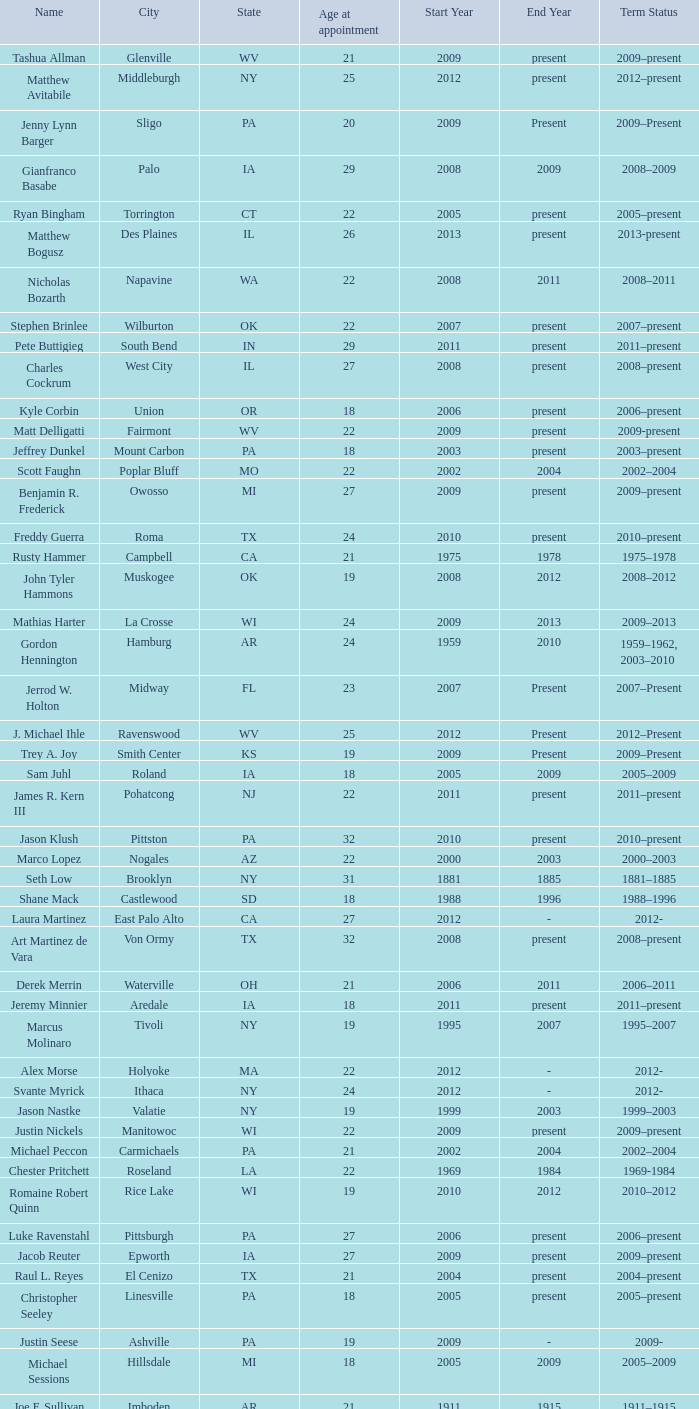What is the name of the holland locale Philip A. Tanis. 